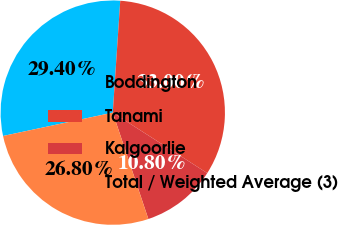Convert chart. <chart><loc_0><loc_0><loc_500><loc_500><pie_chart><fcel>Boddington<fcel>Tanami<fcel>Kalgoorlie<fcel>Total / Weighted Average (3)<nl><fcel>29.4%<fcel>33.0%<fcel>10.8%<fcel>26.8%<nl></chart> 